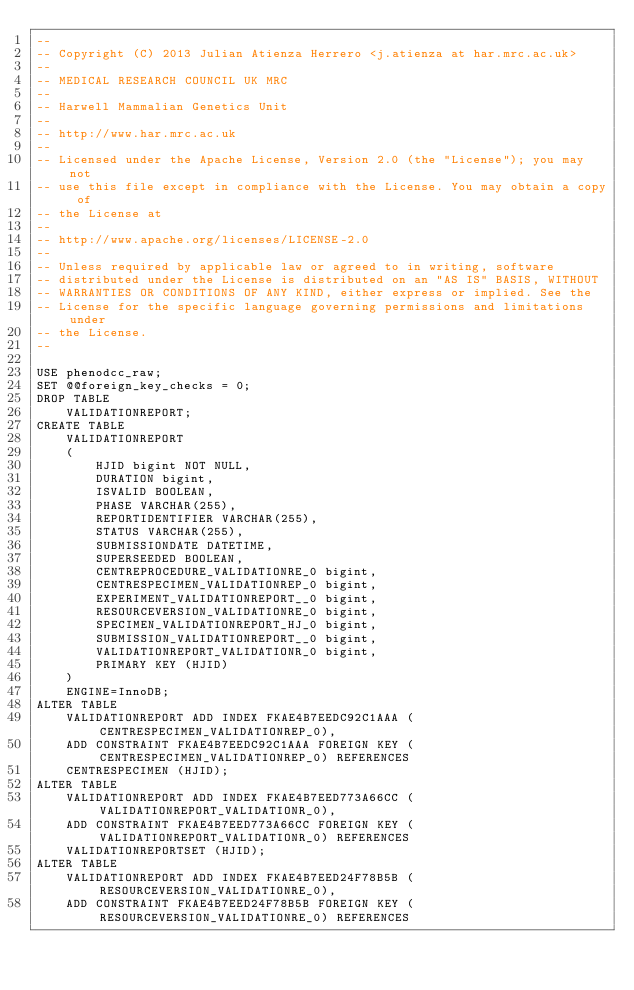<code> <loc_0><loc_0><loc_500><loc_500><_SQL_>--
-- Copyright (C) 2013 Julian Atienza Herrero <j.atienza at har.mrc.ac.uk>
--
-- MEDICAL RESEARCH COUNCIL UK MRC
--
-- Harwell Mammalian Genetics Unit
--
-- http://www.har.mrc.ac.uk
--
-- Licensed under the Apache License, Version 2.0 (the "License"); you may not
-- use this file except in compliance with the License. You may obtain a copy of
-- the License at
--
-- http://www.apache.org/licenses/LICENSE-2.0
--
-- Unless required by applicable law or agreed to in writing, software
-- distributed under the License is distributed on an "AS IS" BASIS, WITHOUT
-- WARRANTIES OR CONDITIONS OF ANY KIND, either express or implied. See the
-- License for the specific language governing permissions and limitations under
-- the License.
--

USE phenodcc_raw;
SET @@foreign_key_checks = 0;
DROP TABLE
    VALIDATIONREPORT;
CREATE TABLE
    VALIDATIONREPORT
    (
        HJID bigint NOT NULL,
        DURATION bigint,
        ISVALID BOOLEAN,
        PHASE VARCHAR(255),
        REPORTIDENTIFIER VARCHAR(255),
        STATUS VARCHAR(255),
        SUBMISSIONDATE DATETIME,
        SUPERSEEDED BOOLEAN,
        CENTREPROCEDURE_VALIDATIONRE_0 bigint,
        CENTRESPECIMEN_VALIDATIONREP_0 bigint,
        EXPERIMENT_VALIDATIONREPORT__0 bigint,
        RESOURCEVERSION_VALIDATIONRE_0 bigint,
        SPECIMEN_VALIDATIONREPORT_HJ_0 bigint,
        SUBMISSION_VALIDATIONREPORT__0 bigint,
        VALIDATIONREPORT_VALIDATIONR_0 bigint,
        PRIMARY KEY (HJID)
    )
    ENGINE=InnoDB;
ALTER TABLE
    VALIDATIONREPORT ADD INDEX FKAE4B7EEDC92C1AAA (CENTRESPECIMEN_VALIDATIONREP_0),
    ADD CONSTRAINT FKAE4B7EEDC92C1AAA FOREIGN KEY (CENTRESPECIMEN_VALIDATIONREP_0) REFERENCES
    CENTRESPECIMEN (HJID);
ALTER TABLE
    VALIDATIONREPORT ADD INDEX FKAE4B7EED773A66CC (VALIDATIONREPORT_VALIDATIONR_0),
    ADD CONSTRAINT FKAE4B7EED773A66CC FOREIGN KEY (VALIDATIONREPORT_VALIDATIONR_0) REFERENCES
    VALIDATIONREPORTSET (HJID);
ALTER TABLE
    VALIDATIONREPORT ADD INDEX FKAE4B7EED24F78B5B (RESOURCEVERSION_VALIDATIONRE_0),
    ADD CONSTRAINT FKAE4B7EED24F78B5B FOREIGN KEY (RESOURCEVERSION_VALIDATIONRE_0) REFERENCES</code> 